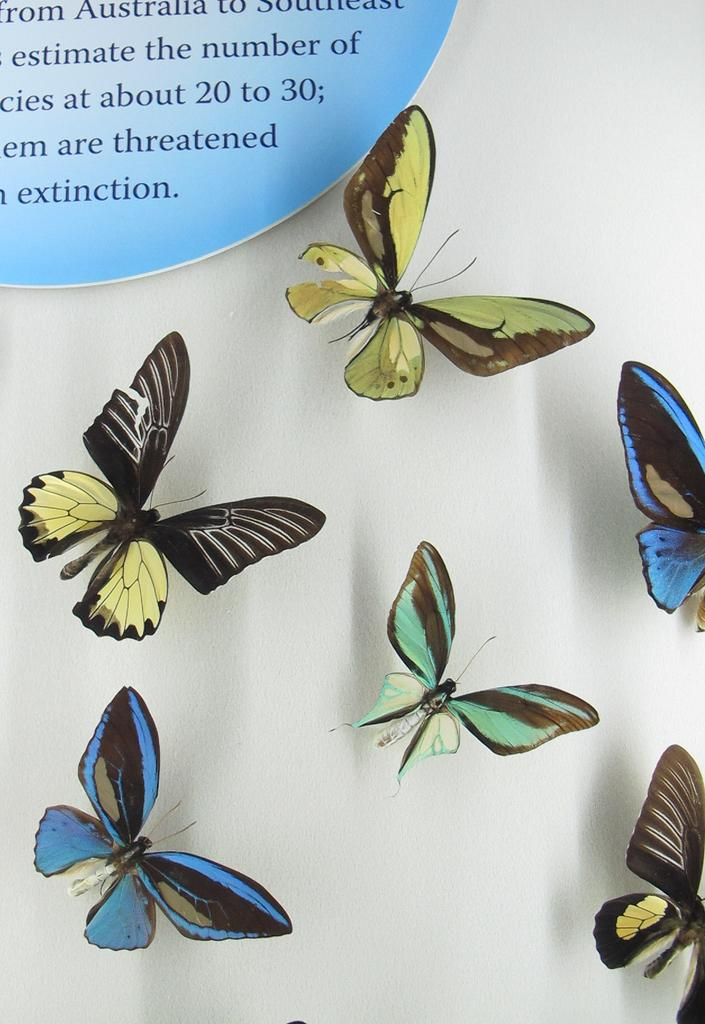What type of animals can be seen in the image? There are butterflies in the image. What is present in the top left corner of the image? There is edited text in the top left corner of the image. What color is the background of the image? The background of the image is white. How many mice are playing the harmonica in the image? There are no mice or harmonicas present in the image; it features butterflies and edited text. What type of manager is depicted in the image? There is no manager depicted in the image; it features butterflies and edited text. 